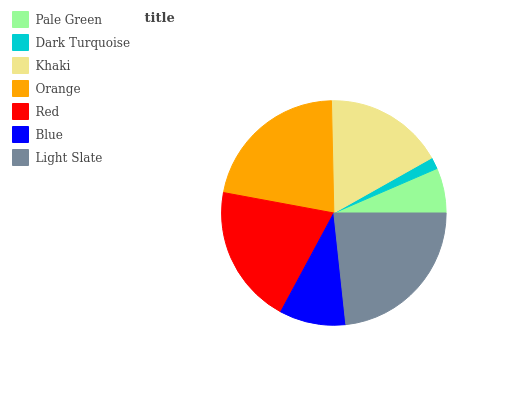Is Dark Turquoise the minimum?
Answer yes or no. Yes. Is Light Slate the maximum?
Answer yes or no. Yes. Is Khaki the minimum?
Answer yes or no. No. Is Khaki the maximum?
Answer yes or no. No. Is Khaki greater than Dark Turquoise?
Answer yes or no. Yes. Is Dark Turquoise less than Khaki?
Answer yes or no. Yes. Is Dark Turquoise greater than Khaki?
Answer yes or no. No. Is Khaki less than Dark Turquoise?
Answer yes or no. No. Is Khaki the high median?
Answer yes or no. Yes. Is Khaki the low median?
Answer yes or no. Yes. Is Orange the high median?
Answer yes or no. No. Is Red the low median?
Answer yes or no. No. 